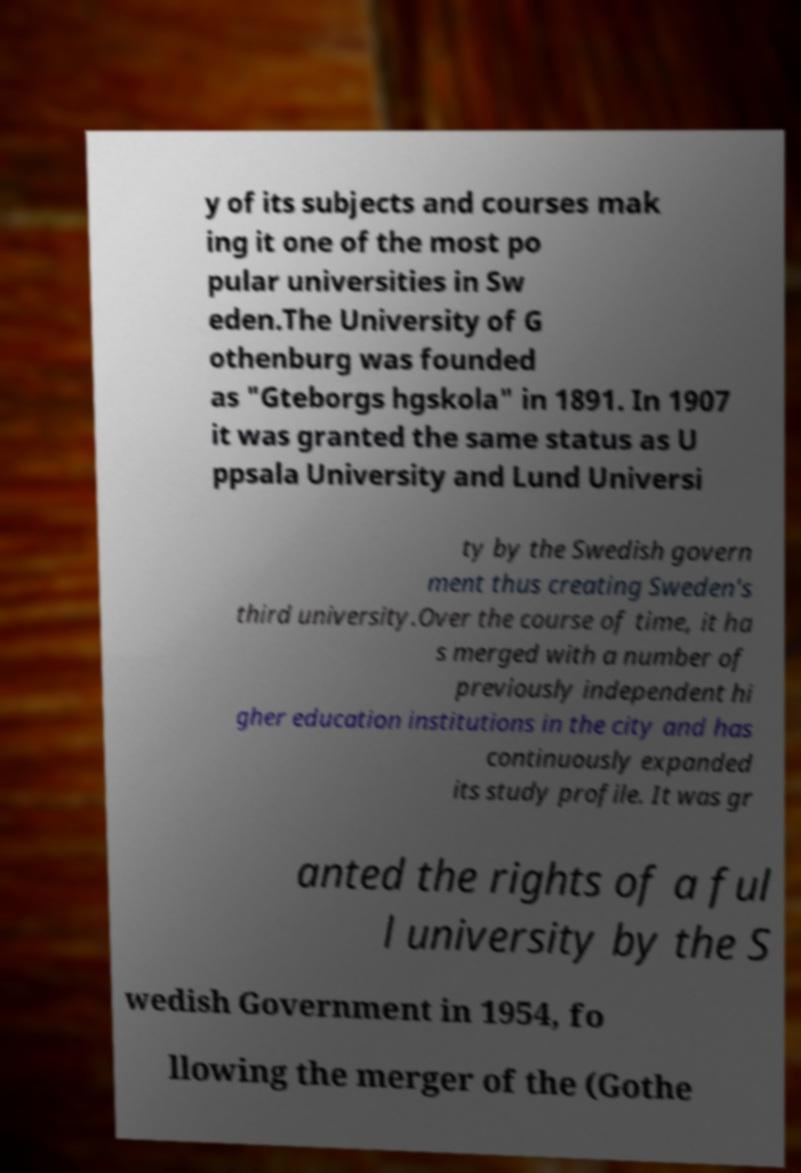For documentation purposes, I need the text within this image transcribed. Could you provide that? y of its subjects and courses mak ing it one of the most po pular universities in Sw eden.The University of G othenburg was founded as "Gteborgs hgskola" in 1891. In 1907 it was granted the same status as U ppsala University and Lund Universi ty by the Swedish govern ment thus creating Sweden's third university.Over the course of time, it ha s merged with a number of previously independent hi gher education institutions in the city and has continuously expanded its study profile. It was gr anted the rights of a ful l university by the S wedish Government in 1954, fo llowing the merger of the (Gothe 